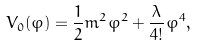<formula> <loc_0><loc_0><loc_500><loc_500>V _ { 0 } ( \varphi ) = \frac { 1 } { 2 } m ^ { 2 } \varphi ^ { 2 } + \frac { \lambda } { 4 ! } \varphi ^ { 4 } ,</formula> 